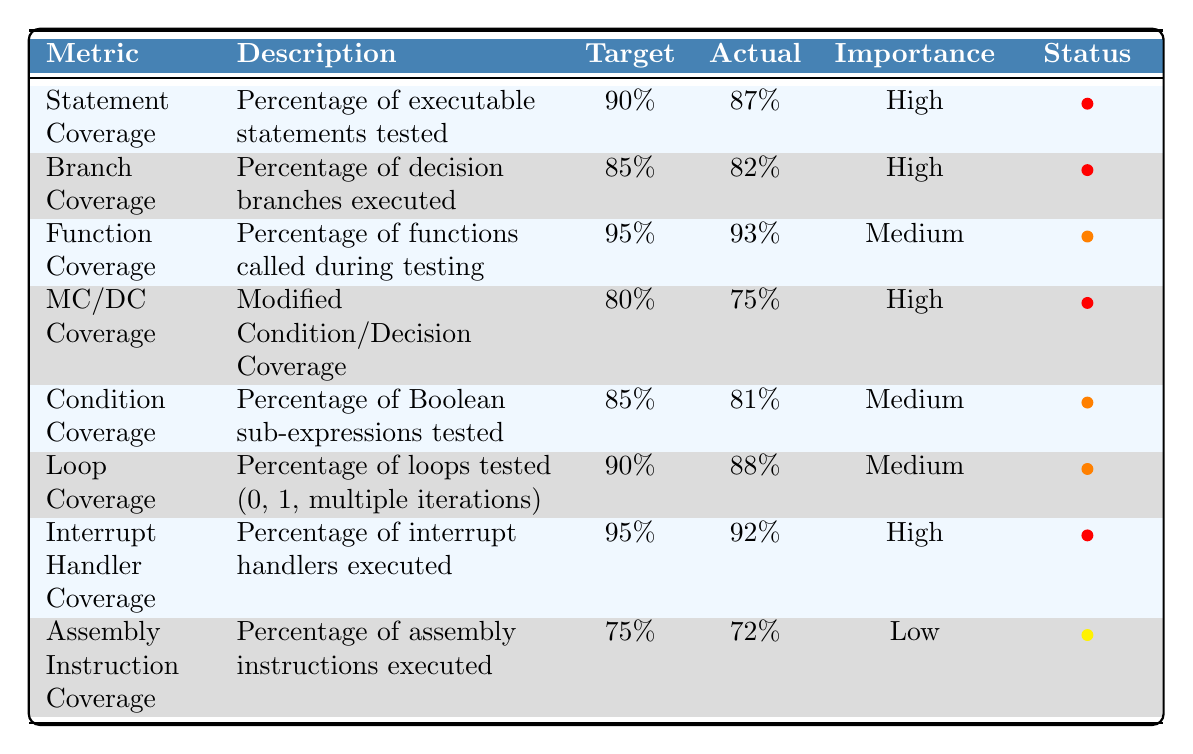What is the actual Statement Coverage percentage? The table shows that the actual Statement Coverage percentage is listed under the "Actual" column for Statement Coverage, which is 87%.
Answer: 87% What is the target for Loop Coverage? The table indicates that the target for Loop Coverage is provided in the "Target" column for Loop Coverage, which is 90%.
Answer: 90% Is the actual Function Coverage above or below the target? The actual Function Coverage is 93%, which is above the target of 95%.
Answer: Below What is the difference between the target and the actual MC/DC Coverage? The target for MC/DC Coverage is 80%, and the actual is 75%. The difference is calculated as 80% - 75% = 5%.
Answer: 5% Which metrics have a High importance status? The "Importance" column categorizes several metrics as High, including Statement Coverage, Branch Coverage, MC/DC Coverage, and Interrupt Handler Coverage.
Answer: Statement, Branch, MC/DC, Interrupt Handler What is the average actual coverage percentage for the Medium importance metrics? The actual percentages for Medium importance metrics are 93%, 81%, 88%, leading to an average of (93% + 81% + 88%) / 3 = 87.33%.
Answer: 87.33% Which coverage metric has the lowest actual value? By reviewing the "Actual" column, Assembly Instruction Coverage has the lowest actual value at 72%.
Answer: 72% Is the actual Interrupt Handler Coverage less than the target? The actual Interrupt Handler Coverage is 92%, while the target is 95%, indicating it is indeed less than the target.
Answer: Yes What is the percentage of actual Condition Coverage, and how does it compare to its target? The actual Condition Coverage is 81%, which is below the target of 85%.
Answer: 81%, Below How many metrics have an actual coverage below their targets? By examining the table, Statement Coverage, Branch Coverage, MC/DC Coverage, and Assembly Instruction Coverage all have actual values below targets, totaling four metrics.
Answer: 4 